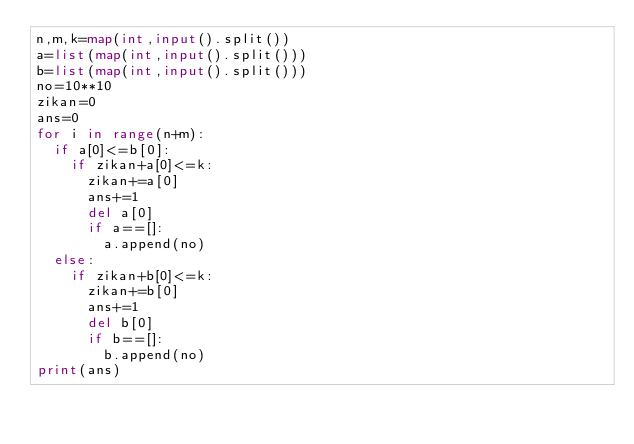Convert code to text. <code><loc_0><loc_0><loc_500><loc_500><_Python_>n,m,k=map(int,input().split())
a=list(map(int,input().split()))
b=list(map(int,input().split()))
no=10**10
zikan=0
ans=0
for i in range(n+m):
  if a[0]<=b[0]:
    if zikan+a[0]<=k:
      zikan+=a[0]
      ans+=1
      del a[0]
      if a==[]:
        a.append(no)
  else:
    if zikan+b[0]<=k:
      zikan+=b[0]
      ans+=1
      del b[0]
      if b==[]:
        b.append(no)
print(ans)</code> 